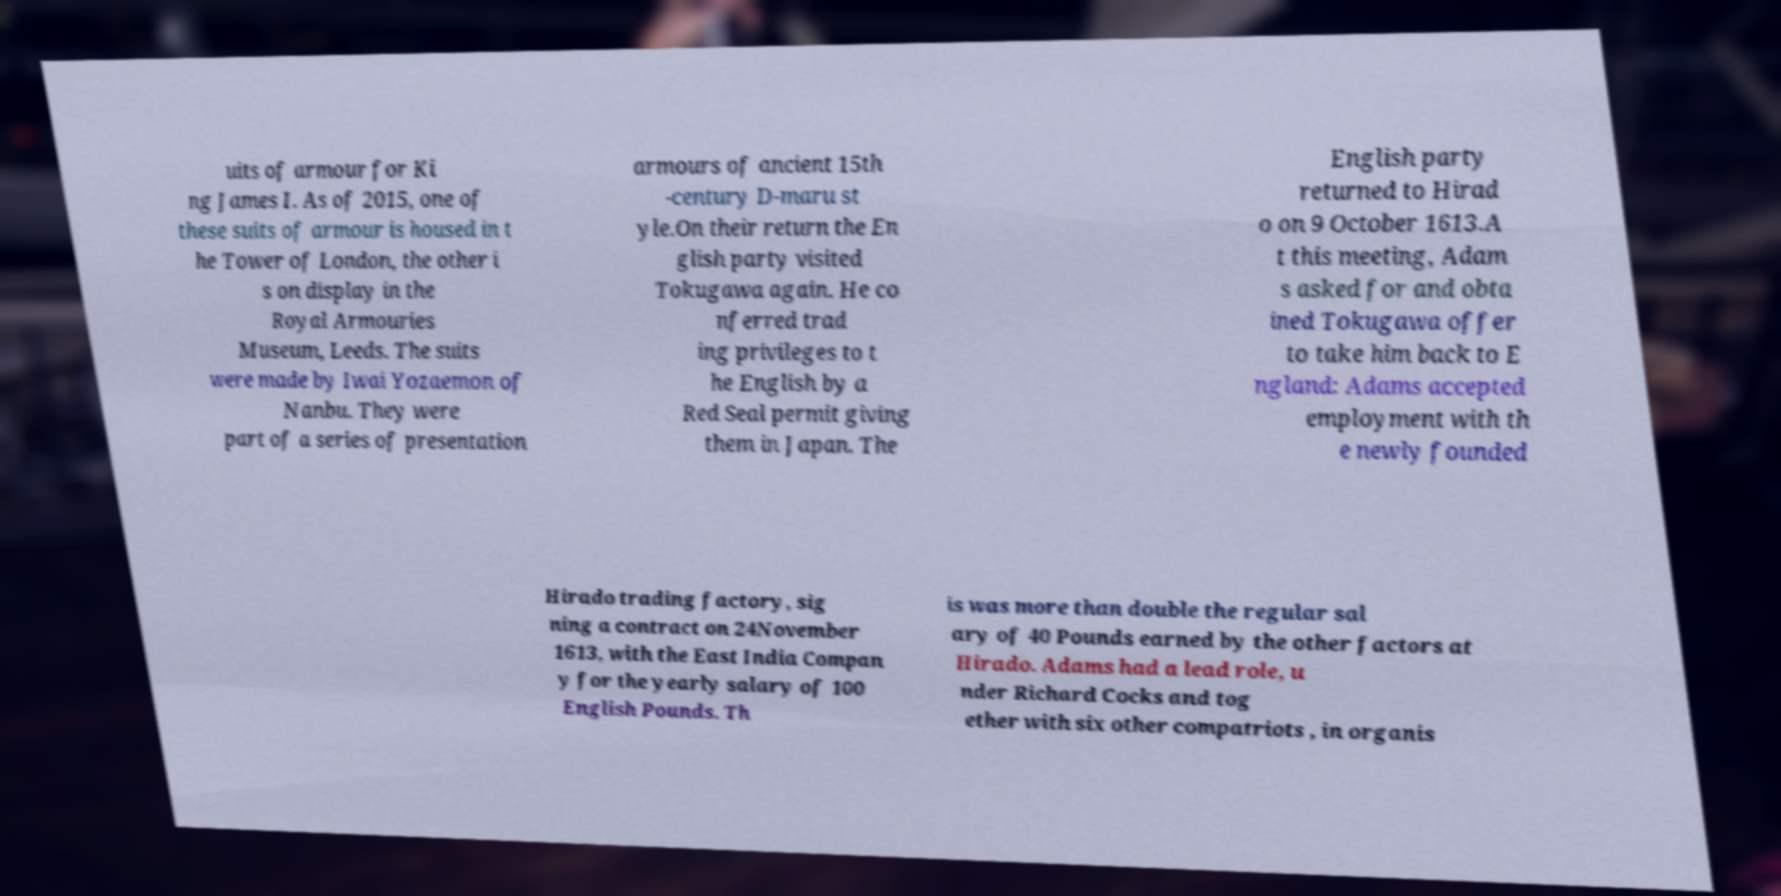Please read and relay the text visible in this image. What does it say? uits of armour for Ki ng James I. As of 2015, one of these suits of armour is housed in t he Tower of London, the other i s on display in the Royal Armouries Museum, Leeds. The suits were made by Iwai Yozaemon of Nanbu. They were part of a series of presentation armours of ancient 15th -century D-maru st yle.On their return the En glish party visited Tokugawa again. He co nferred trad ing privileges to t he English by a Red Seal permit giving them in Japan. The English party returned to Hirad o on 9 October 1613.A t this meeting, Adam s asked for and obta ined Tokugawa offer to take him back to E ngland: Adams accepted employment with th e newly founded Hirado trading factory, sig ning a contract on 24November 1613, with the East India Compan y for the yearly salary of 100 English Pounds. Th is was more than double the regular sal ary of 40 Pounds earned by the other factors at Hirado. Adams had a lead role, u nder Richard Cocks and tog ether with six other compatriots , in organis 